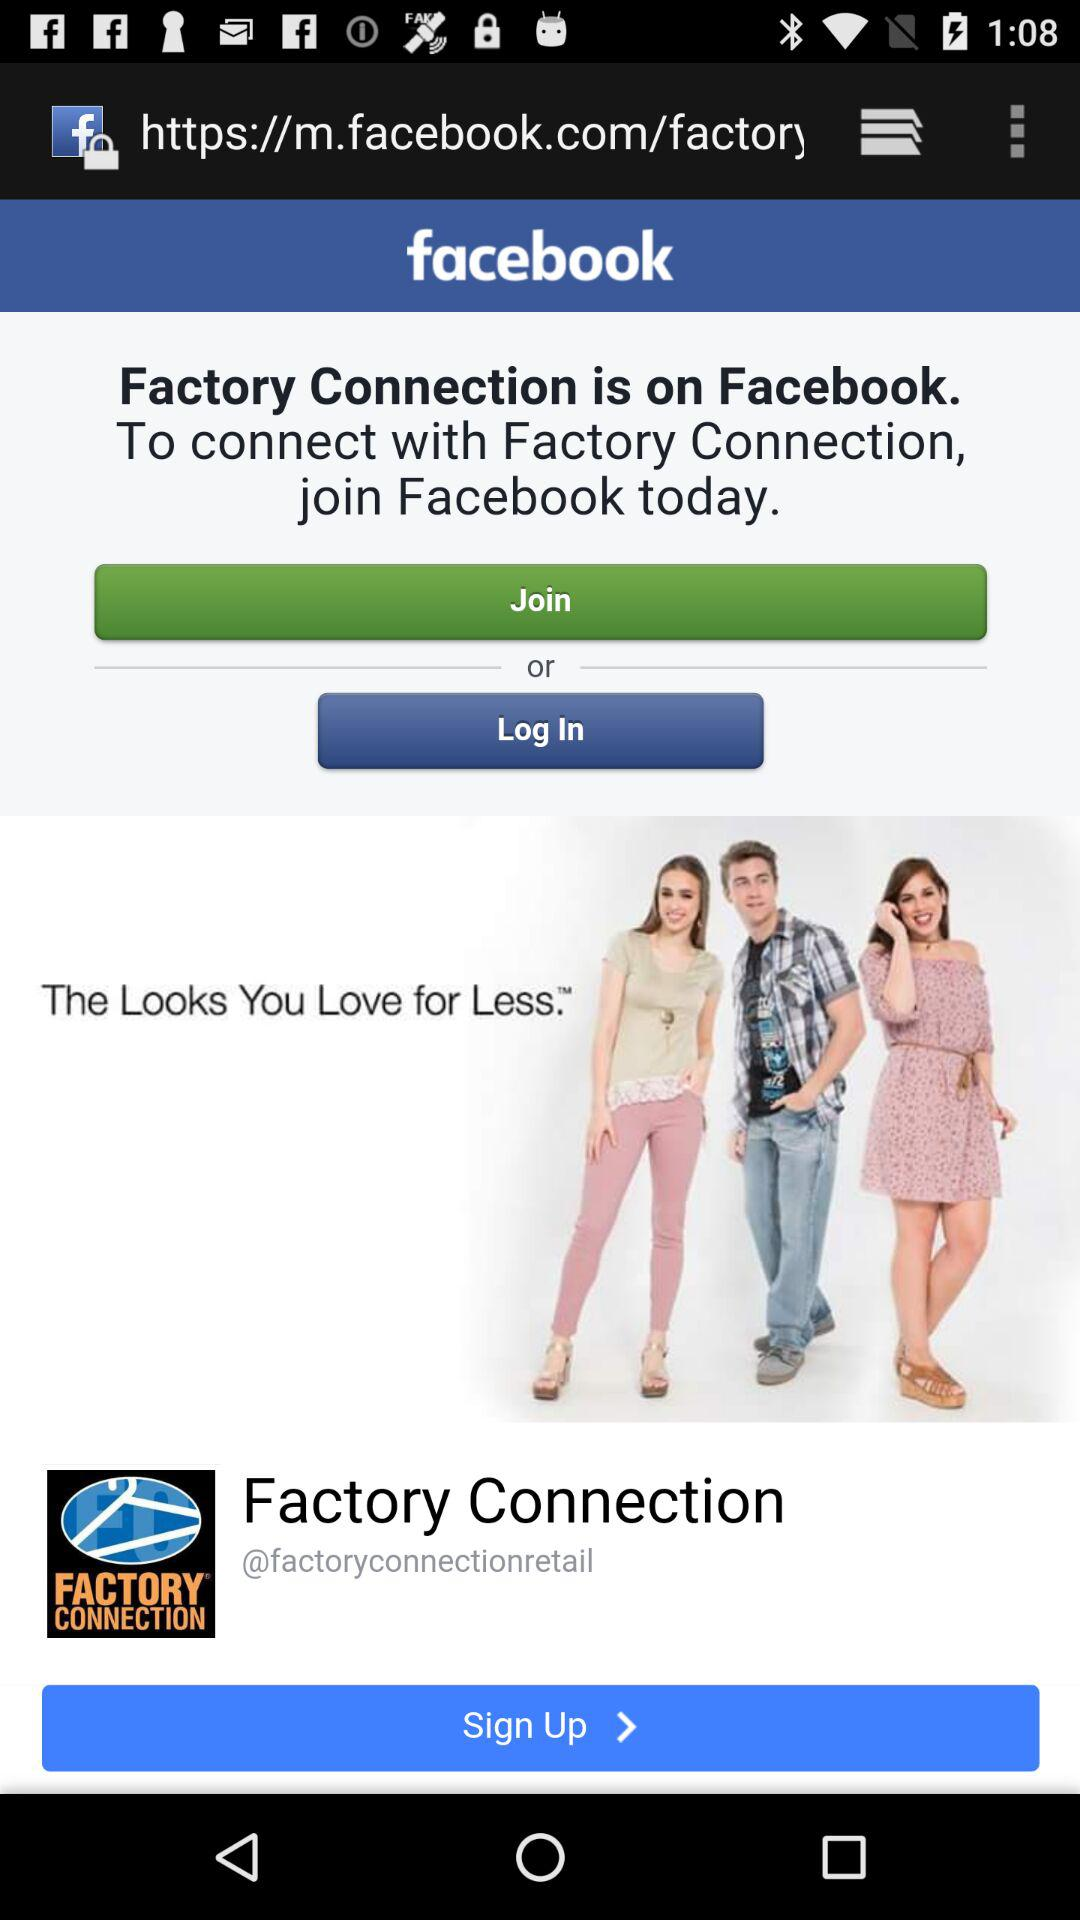What is the name of the application? The name of the application is "facebook". 